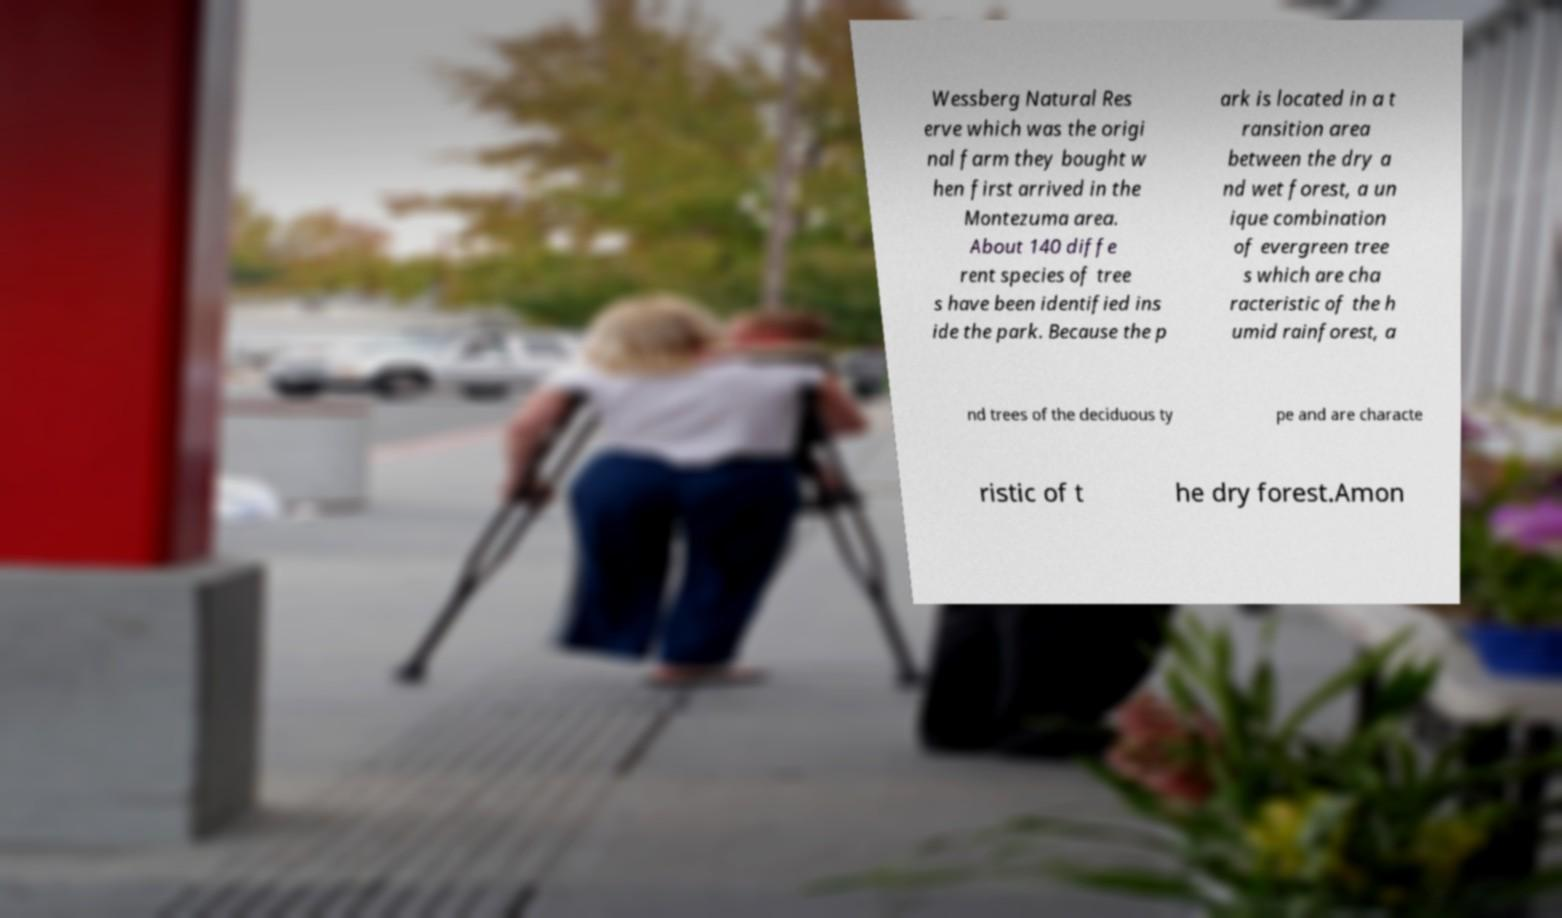Please identify and transcribe the text found in this image. Wessberg Natural Res erve which was the origi nal farm they bought w hen first arrived in the Montezuma area. About 140 diffe rent species of tree s have been identified ins ide the park. Because the p ark is located in a t ransition area between the dry a nd wet forest, a un ique combination of evergreen tree s which are cha racteristic of the h umid rainforest, a nd trees of the deciduous ty pe and are characte ristic of t he dry forest.Amon 